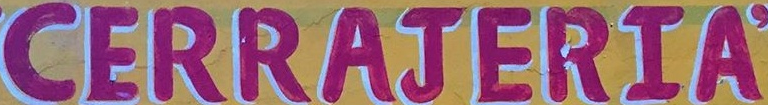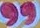What words can you see in these images in sequence, separated by a semicolon? CERRAJERIA; " 